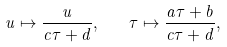Convert formula to latex. <formula><loc_0><loc_0><loc_500><loc_500>u \mapsto \frac { u } { c \tau + d } , \quad \tau \mapsto \frac { a \tau + b } { c \tau + d } ,</formula> 